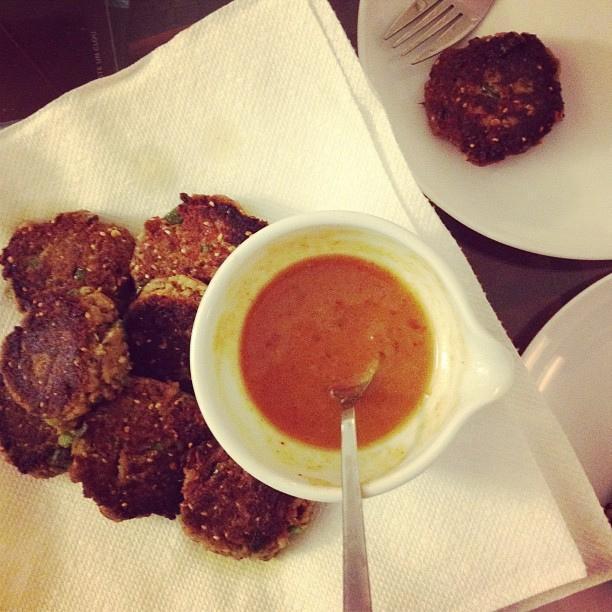How many tines are on the fork?
Give a very brief answer. 4. How many cakes can be seen?
Give a very brief answer. 3. 